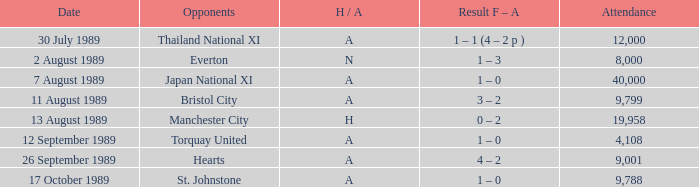How many people attended the match when Manchester United played against the Hearts? 9001.0. 